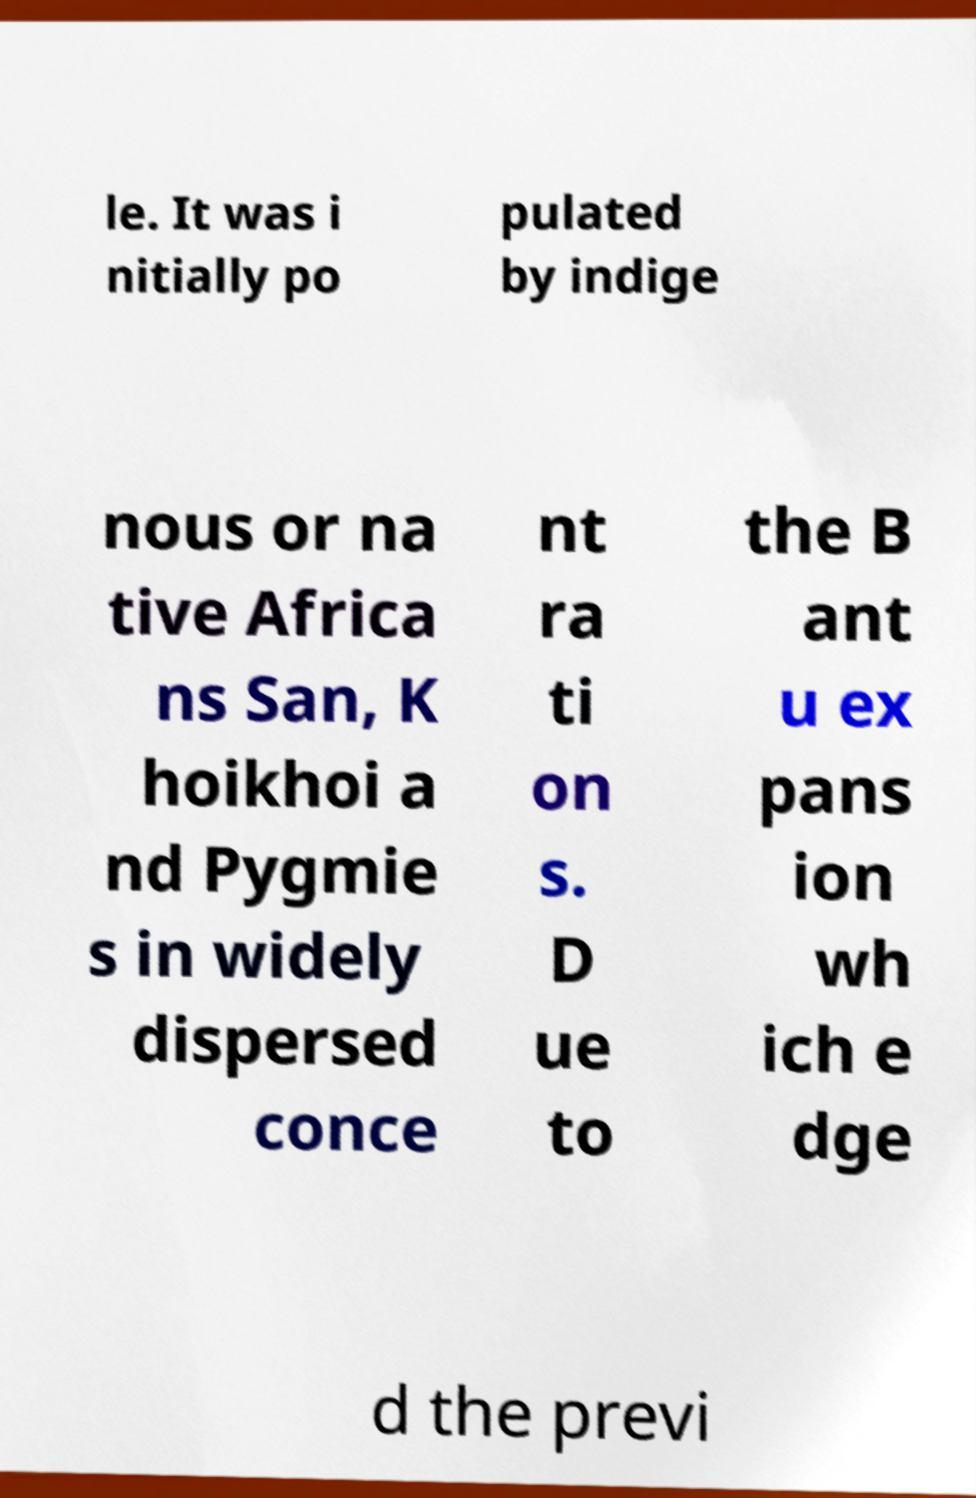Could you extract and type out the text from this image? le. It was i nitially po pulated by indige nous or na tive Africa ns San, K hoikhoi a nd Pygmie s in widely dispersed conce nt ra ti on s. D ue to the B ant u ex pans ion wh ich e dge d the previ 